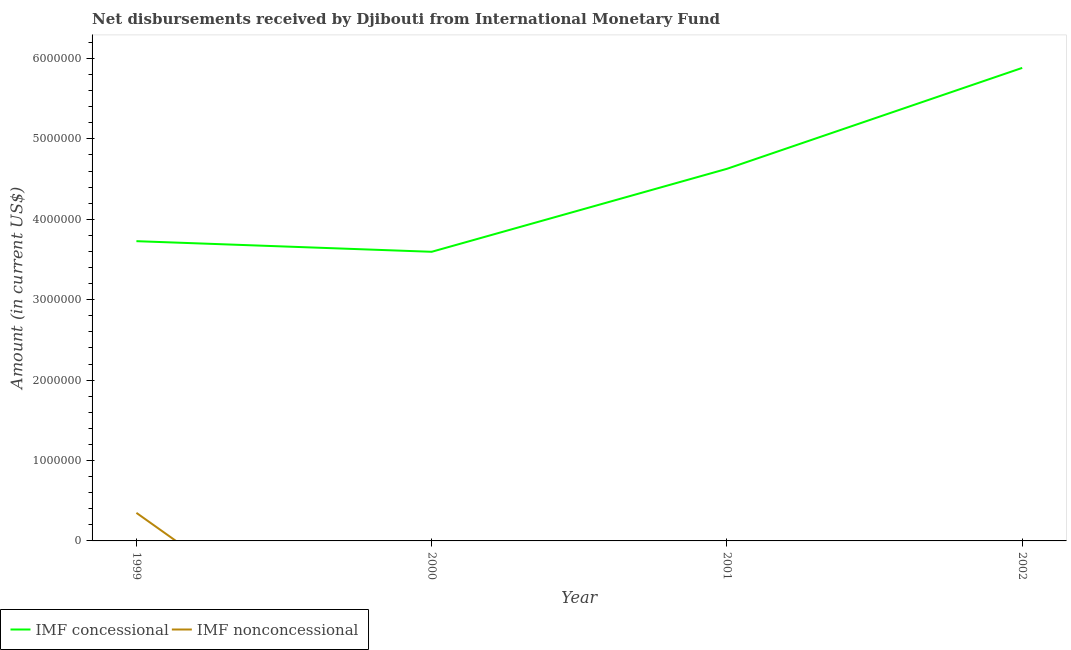Does the line corresponding to net non concessional disbursements from imf intersect with the line corresponding to net concessional disbursements from imf?
Provide a succinct answer. No. Is the number of lines equal to the number of legend labels?
Keep it short and to the point. No. What is the net concessional disbursements from imf in 1999?
Keep it short and to the point. 3.73e+06. Across all years, what is the maximum net non concessional disbursements from imf?
Provide a succinct answer. 3.49e+05. In which year was the net non concessional disbursements from imf maximum?
Give a very brief answer. 1999. What is the total net non concessional disbursements from imf in the graph?
Offer a very short reply. 3.49e+05. What is the difference between the net concessional disbursements from imf in 2000 and that in 2001?
Make the answer very short. -1.03e+06. What is the difference between the net non concessional disbursements from imf in 2001 and the net concessional disbursements from imf in 2002?
Provide a short and direct response. -5.88e+06. What is the average net non concessional disbursements from imf per year?
Give a very brief answer. 8.72e+04. In the year 1999, what is the difference between the net non concessional disbursements from imf and net concessional disbursements from imf?
Provide a short and direct response. -3.38e+06. In how many years, is the net concessional disbursements from imf greater than 3400000 US$?
Your answer should be compact. 4. What is the ratio of the net concessional disbursements from imf in 2001 to that in 2002?
Give a very brief answer. 0.79. Is the net concessional disbursements from imf in 1999 less than that in 2000?
Make the answer very short. No. What is the difference between the highest and the second highest net concessional disbursements from imf?
Give a very brief answer. 1.26e+06. What is the difference between the highest and the lowest net concessional disbursements from imf?
Make the answer very short. 2.29e+06. Is the sum of the net concessional disbursements from imf in 1999 and 2002 greater than the maximum net non concessional disbursements from imf across all years?
Provide a succinct answer. Yes. Does the net concessional disbursements from imf monotonically increase over the years?
Ensure brevity in your answer.  No. Is the net concessional disbursements from imf strictly greater than the net non concessional disbursements from imf over the years?
Offer a terse response. Yes. Is the net non concessional disbursements from imf strictly less than the net concessional disbursements from imf over the years?
Your answer should be compact. Yes. How many years are there in the graph?
Your response must be concise. 4. What is the difference between two consecutive major ticks on the Y-axis?
Make the answer very short. 1.00e+06. Are the values on the major ticks of Y-axis written in scientific E-notation?
Make the answer very short. No. Does the graph contain grids?
Your answer should be very brief. No. What is the title of the graph?
Provide a succinct answer. Net disbursements received by Djibouti from International Monetary Fund. Does "Money lenders" appear as one of the legend labels in the graph?
Provide a succinct answer. No. What is the label or title of the X-axis?
Keep it short and to the point. Year. What is the Amount (in current US$) of IMF concessional in 1999?
Keep it short and to the point. 3.73e+06. What is the Amount (in current US$) of IMF nonconcessional in 1999?
Your answer should be very brief. 3.49e+05. What is the Amount (in current US$) in IMF concessional in 2000?
Keep it short and to the point. 3.60e+06. What is the Amount (in current US$) in IMF concessional in 2001?
Keep it short and to the point. 4.63e+06. What is the Amount (in current US$) of IMF nonconcessional in 2001?
Offer a terse response. 0. What is the Amount (in current US$) in IMF concessional in 2002?
Provide a succinct answer. 5.88e+06. Across all years, what is the maximum Amount (in current US$) of IMF concessional?
Offer a very short reply. 5.88e+06. Across all years, what is the maximum Amount (in current US$) in IMF nonconcessional?
Your answer should be very brief. 3.49e+05. Across all years, what is the minimum Amount (in current US$) of IMF concessional?
Your answer should be compact. 3.60e+06. Across all years, what is the minimum Amount (in current US$) in IMF nonconcessional?
Offer a very short reply. 0. What is the total Amount (in current US$) of IMF concessional in the graph?
Your response must be concise. 1.78e+07. What is the total Amount (in current US$) in IMF nonconcessional in the graph?
Your answer should be very brief. 3.49e+05. What is the difference between the Amount (in current US$) in IMF concessional in 1999 and that in 2000?
Offer a terse response. 1.32e+05. What is the difference between the Amount (in current US$) in IMF concessional in 1999 and that in 2001?
Ensure brevity in your answer.  -9.00e+05. What is the difference between the Amount (in current US$) of IMF concessional in 1999 and that in 2002?
Provide a short and direct response. -2.16e+06. What is the difference between the Amount (in current US$) of IMF concessional in 2000 and that in 2001?
Keep it short and to the point. -1.03e+06. What is the difference between the Amount (in current US$) of IMF concessional in 2000 and that in 2002?
Provide a short and direct response. -2.29e+06. What is the difference between the Amount (in current US$) in IMF concessional in 2001 and that in 2002?
Offer a very short reply. -1.26e+06. What is the average Amount (in current US$) in IMF concessional per year?
Make the answer very short. 4.46e+06. What is the average Amount (in current US$) of IMF nonconcessional per year?
Offer a very short reply. 8.72e+04. In the year 1999, what is the difference between the Amount (in current US$) in IMF concessional and Amount (in current US$) in IMF nonconcessional?
Offer a terse response. 3.38e+06. What is the ratio of the Amount (in current US$) of IMF concessional in 1999 to that in 2000?
Your response must be concise. 1.04. What is the ratio of the Amount (in current US$) of IMF concessional in 1999 to that in 2001?
Your response must be concise. 0.81. What is the ratio of the Amount (in current US$) in IMF concessional in 1999 to that in 2002?
Make the answer very short. 0.63. What is the ratio of the Amount (in current US$) of IMF concessional in 2000 to that in 2001?
Provide a short and direct response. 0.78. What is the ratio of the Amount (in current US$) in IMF concessional in 2000 to that in 2002?
Provide a succinct answer. 0.61. What is the ratio of the Amount (in current US$) of IMF concessional in 2001 to that in 2002?
Your response must be concise. 0.79. What is the difference between the highest and the second highest Amount (in current US$) in IMF concessional?
Ensure brevity in your answer.  1.26e+06. What is the difference between the highest and the lowest Amount (in current US$) in IMF concessional?
Give a very brief answer. 2.29e+06. What is the difference between the highest and the lowest Amount (in current US$) of IMF nonconcessional?
Make the answer very short. 3.49e+05. 